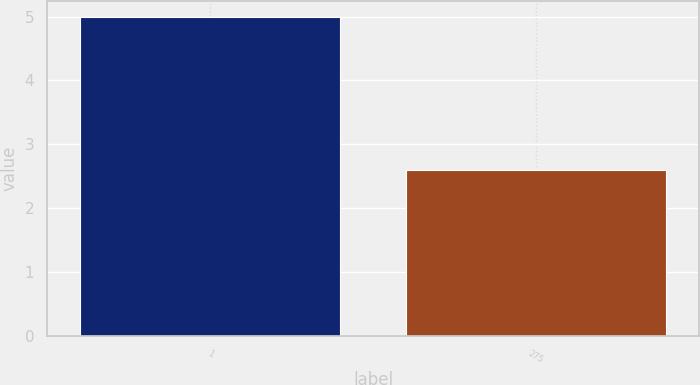Convert chart. <chart><loc_0><loc_0><loc_500><loc_500><bar_chart><fcel>1<fcel>275<nl><fcel>5<fcel>2.6<nl></chart> 